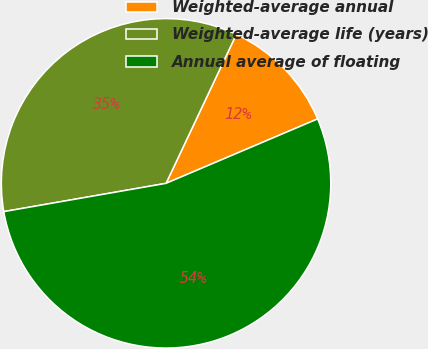<chart> <loc_0><loc_0><loc_500><loc_500><pie_chart><fcel>Weighted-average annual<fcel>Weighted-average life (years)<fcel>Annual average of floating<nl><fcel>11.59%<fcel>34.76%<fcel>53.65%<nl></chart> 